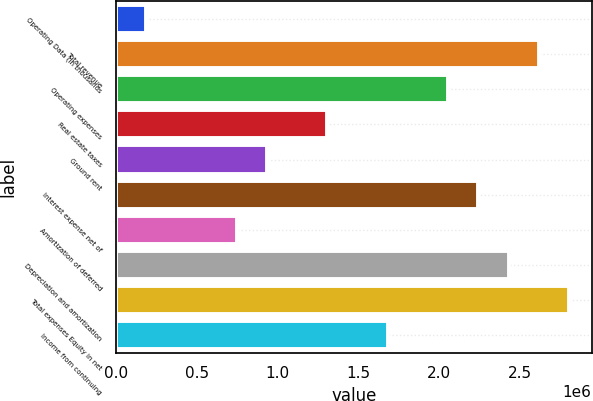Convert chart to OTSL. <chart><loc_0><loc_0><loc_500><loc_500><bar_chart><fcel>Operating Data (in thousands<fcel>Total revenue<fcel>Operating expenses<fcel>Real estate taxes<fcel>Ground rent<fcel>Interest expense net of<fcel>Amortization of deferred<fcel>Depreciation and amortization<fcel>Total expenses Equity in net<fcel>Income from continuing<nl><fcel>186862<fcel>2.61604e+06<fcel>2.05546e+06<fcel>1.30802e+06<fcel>934301<fcel>2.24232e+06<fcel>747441<fcel>2.42918e+06<fcel>2.8029e+06<fcel>1.68174e+06<nl></chart> 